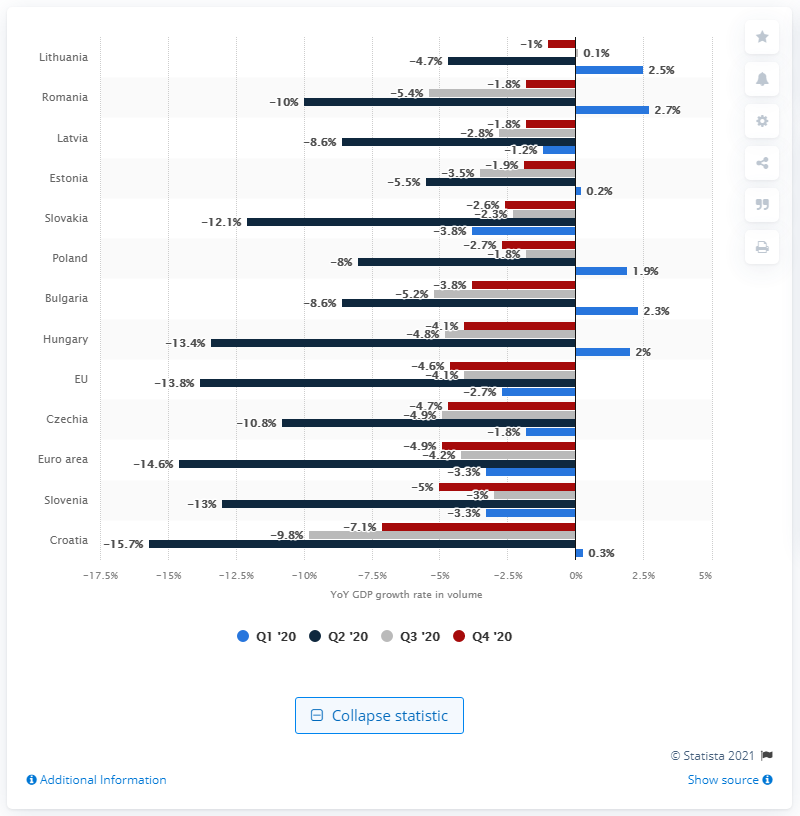Highlight a few significant elements in this photo. Lithuania recorded the lowest GDP decline in the fourth quarter of 2020 among all countries. Croatia has the highest gross domestic product decline among all Central and Eastern European countries. 